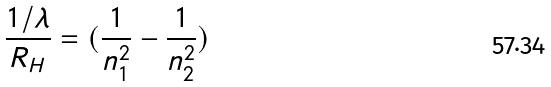Convert formula to latex. <formula><loc_0><loc_0><loc_500><loc_500>\frac { 1 / \lambda } { R _ { H } } = ( \frac { 1 } { n _ { 1 } ^ { 2 } } - \frac { 1 } { n _ { 2 } ^ { 2 } } )</formula> 